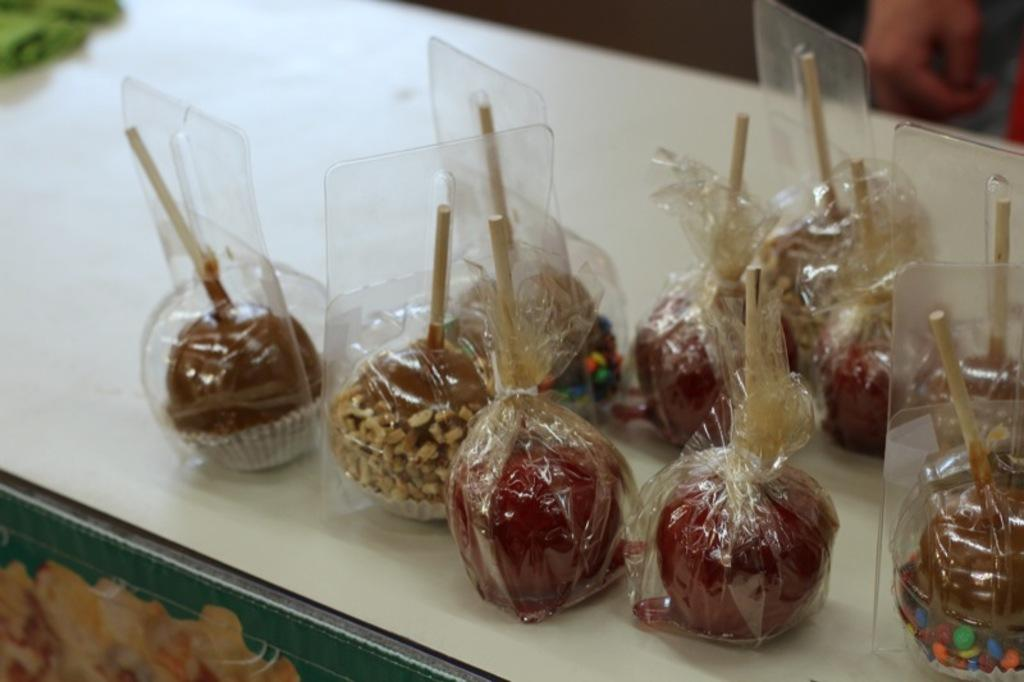What type of food items are on the table in the image? There are candies on the table in the image. Can you describe the person standing in the image? There is a person standing at the top right of the image. What color is the tablecloth on the table? The table has a green cloth on it. What type of mint can be seen growing near the person in the image? A: There is no mint plant visible in the image; it only features candies on the table and a person standing at the top right. 